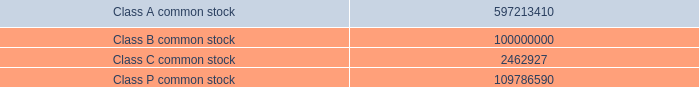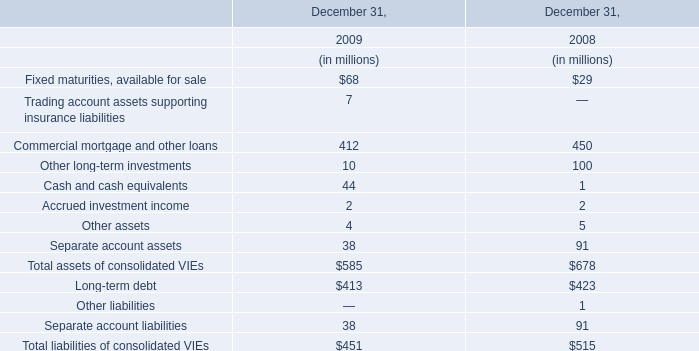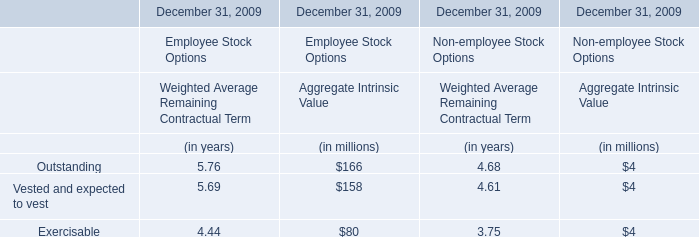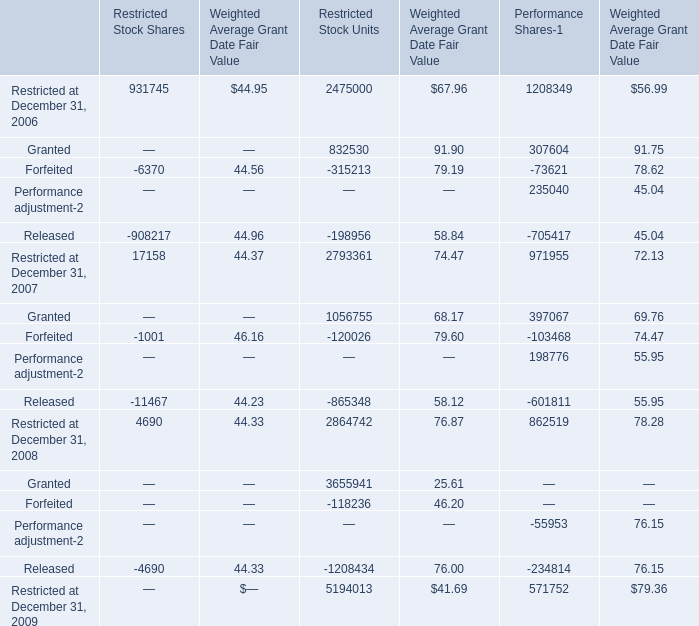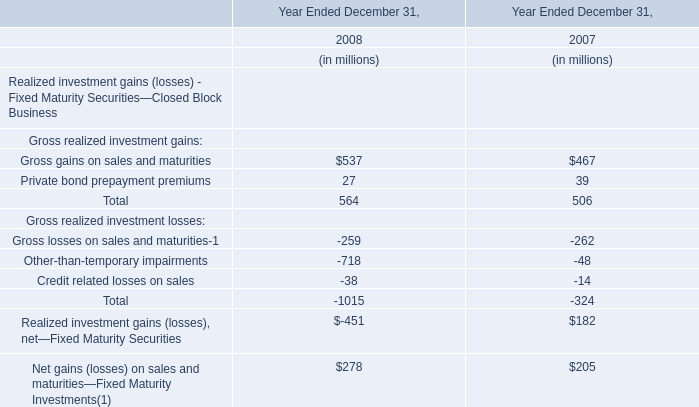what's the total amount of Granted of Restricted Stock Units, and Class B common stock ? 
Computations: (832530.0 + 100000000.0)
Answer: 100832530.0. 